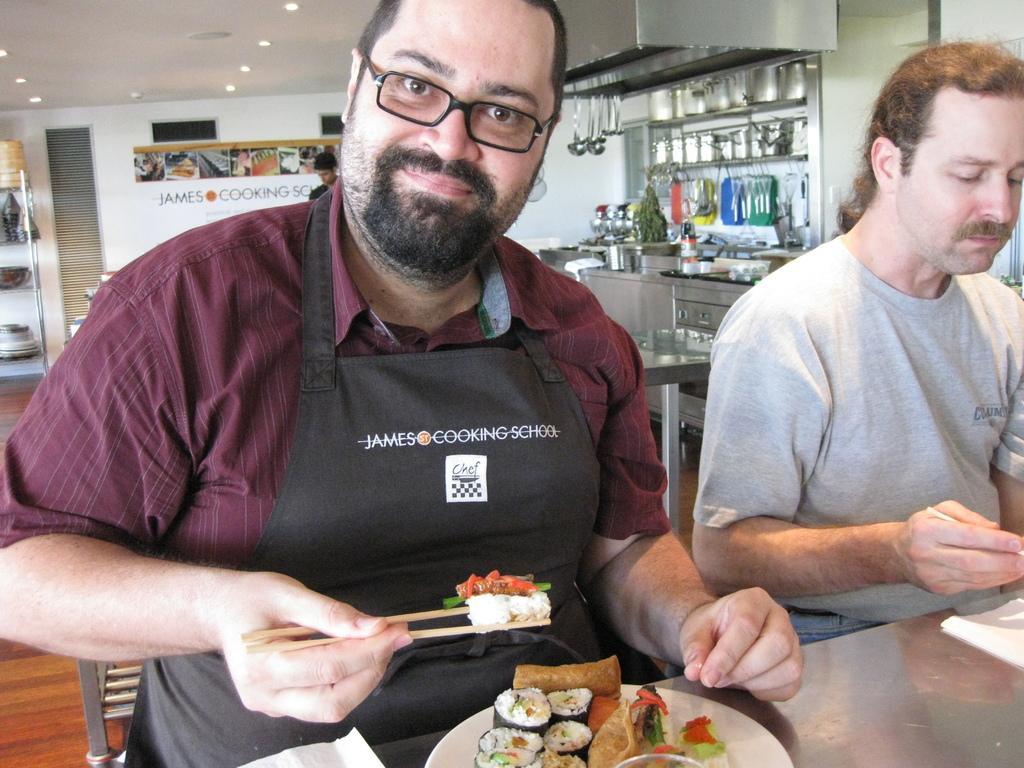Can you describe this image briefly? In this image i can see in side view of a building and there are the two persons sitting in front of the table and a person wearing a brown color shirt on the left side and his holding a food object on his hand ,on the left side a person wearing a gray color t-shirt ,back side of him there is a table , on the table there are some objects kept on the table. 